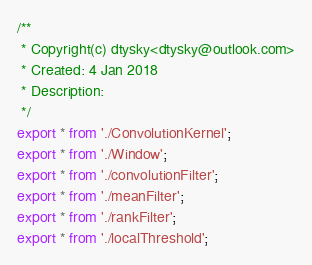<code> <loc_0><loc_0><loc_500><loc_500><_TypeScript_>/**
 * Copyright(c) dtysky<dtysky@outlook.com>
 * Created: 4 Jan 2018
 * Description:
 */
export * from './ConvolutionKernel';
export * from './Window';
export * from './convolutionFilter';
export * from './meanFilter';
export * from './rankFilter';
export * from './localThreshold';
</code> 